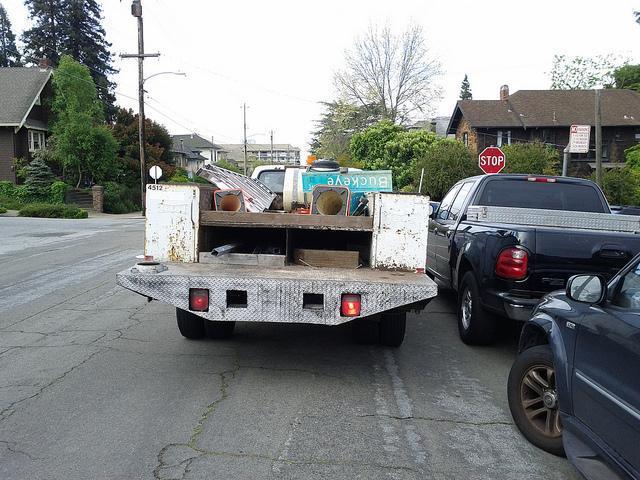How many tires are visible in the image?
Give a very brief answer. 4. How many lanes can be seen?
Give a very brief answer. 2. How many trucks are visible?
Give a very brief answer. 2. How many bikes are in the picture?
Give a very brief answer. 0. 